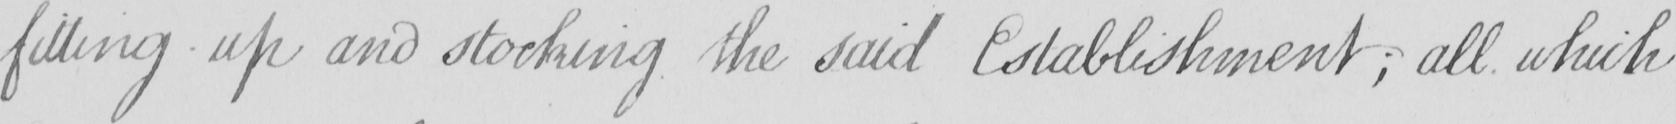Can you read and transcribe this handwriting? fitting up and stocking the said Establishment  ; all which 